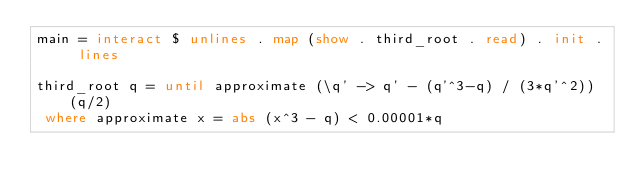Convert code to text. <code><loc_0><loc_0><loc_500><loc_500><_Haskell_>main = interact $ unlines . map (show . third_root . read) . init . lines

third_root q = until approximate (\q' -> q' - (q'^3-q) / (3*q'^2)) (q/2)
 where approximate x = abs (x^3 - q) < 0.00001*q</code> 